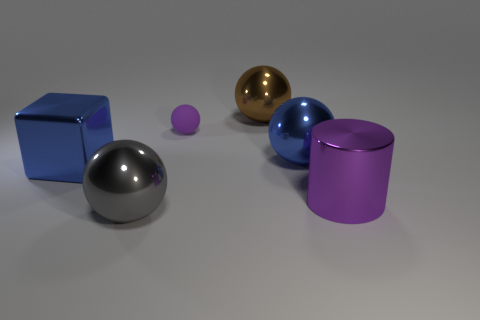Is the tiny matte sphere the same color as the cylinder?
Ensure brevity in your answer.  Yes. What color is the object that is to the right of the small sphere and in front of the blue metallic cube?
Make the answer very short. Purple. Are there fewer large matte balls than matte objects?
Your answer should be compact. Yes. Do the shiny cube and the rubber object that is left of the purple metal cylinder have the same color?
Provide a short and direct response. No. Are there the same number of gray spheres behind the large blue block and big brown objects that are in front of the gray thing?
Your answer should be compact. Yes. How many other gray metal objects have the same shape as the tiny object?
Make the answer very short. 1. Are any tiny rubber spheres visible?
Give a very brief answer. Yes. Does the big block have the same material as the big sphere that is on the right side of the big brown shiny thing?
Keep it short and to the point. Yes. There is a gray sphere that is the same size as the purple cylinder; what material is it?
Offer a very short reply. Metal. Is there a sphere made of the same material as the big gray object?
Your answer should be very brief. Yes. 